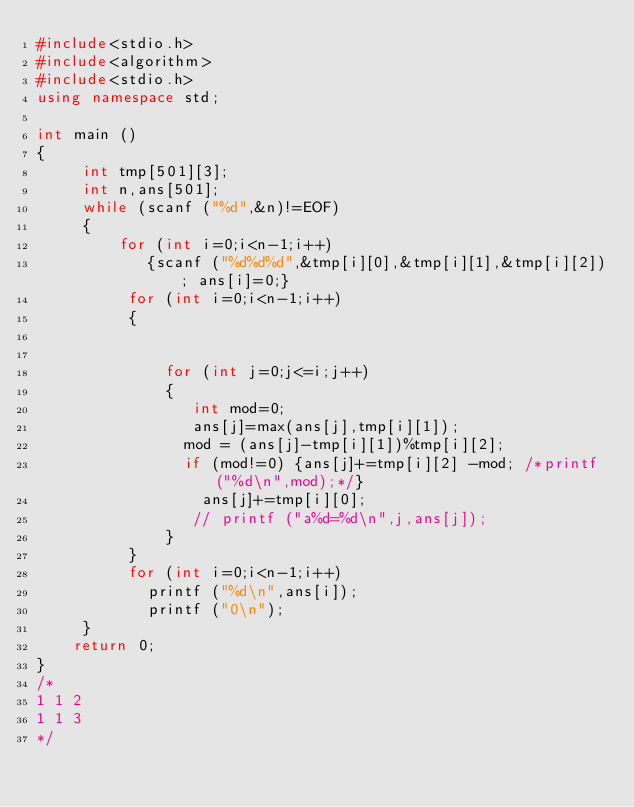<code> <loc_0><loc_0><loc_500><loc_500><_C++_>#include<stdio.h>
#include<algorithm>
#include<stdio.h>
using namespace std;

int main ()
{
     int tmp[501][3];
     int n,ans[501];
     while (scanf ("%d",&n)!=EOF)
     {
         for (int i=0;i<n-1;i++)
            {scanf ("%d%d%d",&tmp[i][0],&tmp[i][1],&tmp[i][2]); ans[i]=0;}
          for (int i=0;i<n-1;i++)
          {


              for (int j=0;j<=i;j++)
              {
                 int mod=0;
                 ans[j]=max(ans[j],tmp[i][1]);
                mod = (ans[j]-tmp[i][1])%tmp[i][2];
                if (mod!=0) {ans[j]+=tmp[i][2] -mod; /*printf ("%d\n",mod);*/}
                  ans[j]+=tmp[i][0];
                 // printf ("a%d=%d\n",j,ans[j]);
              }
          }
          for (int i=0;i<n-1;i++)
            printf ("%d\n",ans[i]);
            printf ("0\n");
     }
    return 0;
}
/*
1 1 2
1 1 3
*/
</code> 